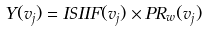<formula> <loc_0><loc_0><loc_500><loc_500>Y ( v _ { j } ) = I S I I F ( v _ { j } ) \times P R _ { w } ( v _ { j } )</formula> 